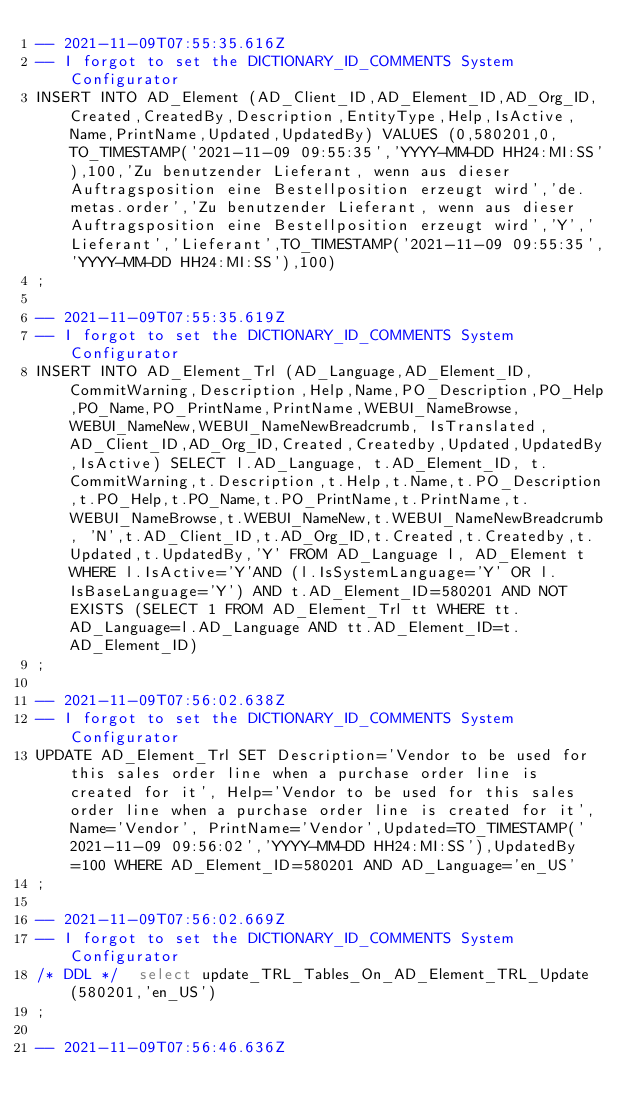<code> <loc_0><loc_0><loc_500><loc_500><_SQL_>-- 2021-11-09T07:55:35.616Z
-- I forgot to set the DICTIONARY_ID_COMMENTS System Configurator
INSERT INTO AD_Element (AD_Client_ID,AD_Element_ID,AD_Org_ID,Created,CreatedBy,Description,EntityType,Help,IsActive,Name,PrintName,Updated,UpdatedBy) VALUES (0,580201,0,TO_TIMESTAMP('2021-11-09 09:55:35','YYYY-MM-DD HH24:MI:SS'),100,'Zu benutzender Lieferant, wenn aus dieser Auftragsposition eine Bestellposition erzeugt wird','de.metas.order','Zu benutzender Lieferant, wenn aus dieser Auftragsposition eine Bestellposition erzeugt wird','Y','Lieferant','Lieferant',TO_TIMESTAMP('2021-11-09 09:55:35','YYYY-MM-DD HH24:MI:SS'),100)
;

-- 2021-11-09T07:55:35.619Z
-- I forgot to set the DICTIONARY_ID_COMMENTS System Configurator
INSERT INTO AD_Element_Trl (AD_Language,AD_Element_ID, CommitWarning,Description,Help,Name,PO_Description,PO_Help,PO_Name,PO_PrintName,PrintName,WEBUI_NameBrowse,WEBUI_NameNew,WEBUI_NameNewBreadcrumb, IsTranslated,AD_Client_ID,AD_Org_ID,Created,Createdby,Updated,UpdatedBy,IsActive) SELECT l.AD_Language, t.AD_Element_ID, t.CommitWarning,t.Description,t.Help,t.Name,t.PO_Description,t.PO_Help,t.PO_Name,t.PO_PrintName,t.PrintName,t.WEBUI_NameBrowse,t.WEBUI_NameNew,t.WEBUI_NameNewBreadcrumb, 'N',t.AD_Client_ID,t.AD_Org_ID,t.Created,t.Createdby,t.Updated,t.UpdatedBy,'Y' FROM AD_Language l, AD_Element t WHERE l.IsActive='Y'AND (l.IsSystemLanguage='Y' OR l.IsBaseLanguage='Y') AND t.AD_Element_ID=580201 AND NOT EXISTS (SELECT 1 FROM AD_Element_Trl tt WHERE tt.AD_Language=l.AD_Language AND tt.AD_Element_ID=t.AD_Element_ID)
;

-- 2021-11-09T07:56:02.638Z
-- I forgot to set the DICTIONARY_ID_COMMENTS System Configurator
UPDATE AD_Element_Trl SET Description='Vendor to be used for this sales order line when a purchase order line is created for it', Help='Vendor to be used for this sales order line when a purchase order line is created for it', Name='Vendor', PrintName='Vendor',Updated=TO_TIMESTAMP('2021-11-09 09:56:02','YYYY-MM-DD HH24:MI:SS'),UpdatedBy=100 WHERE AD_Element_ID=580201 AND AD_Language='en_US'
;

-- 2021-11-09T07:56:02.669Z
-- I forgot to set the DICTIONARY_ID_COMMENTS System Configurator
/* DDL */  select update_TRL_Tables_On_AD_Element_TRL_Update(580201,'en_US') 
;

-- 2021-11-09T07:56:46.636Z</code> 